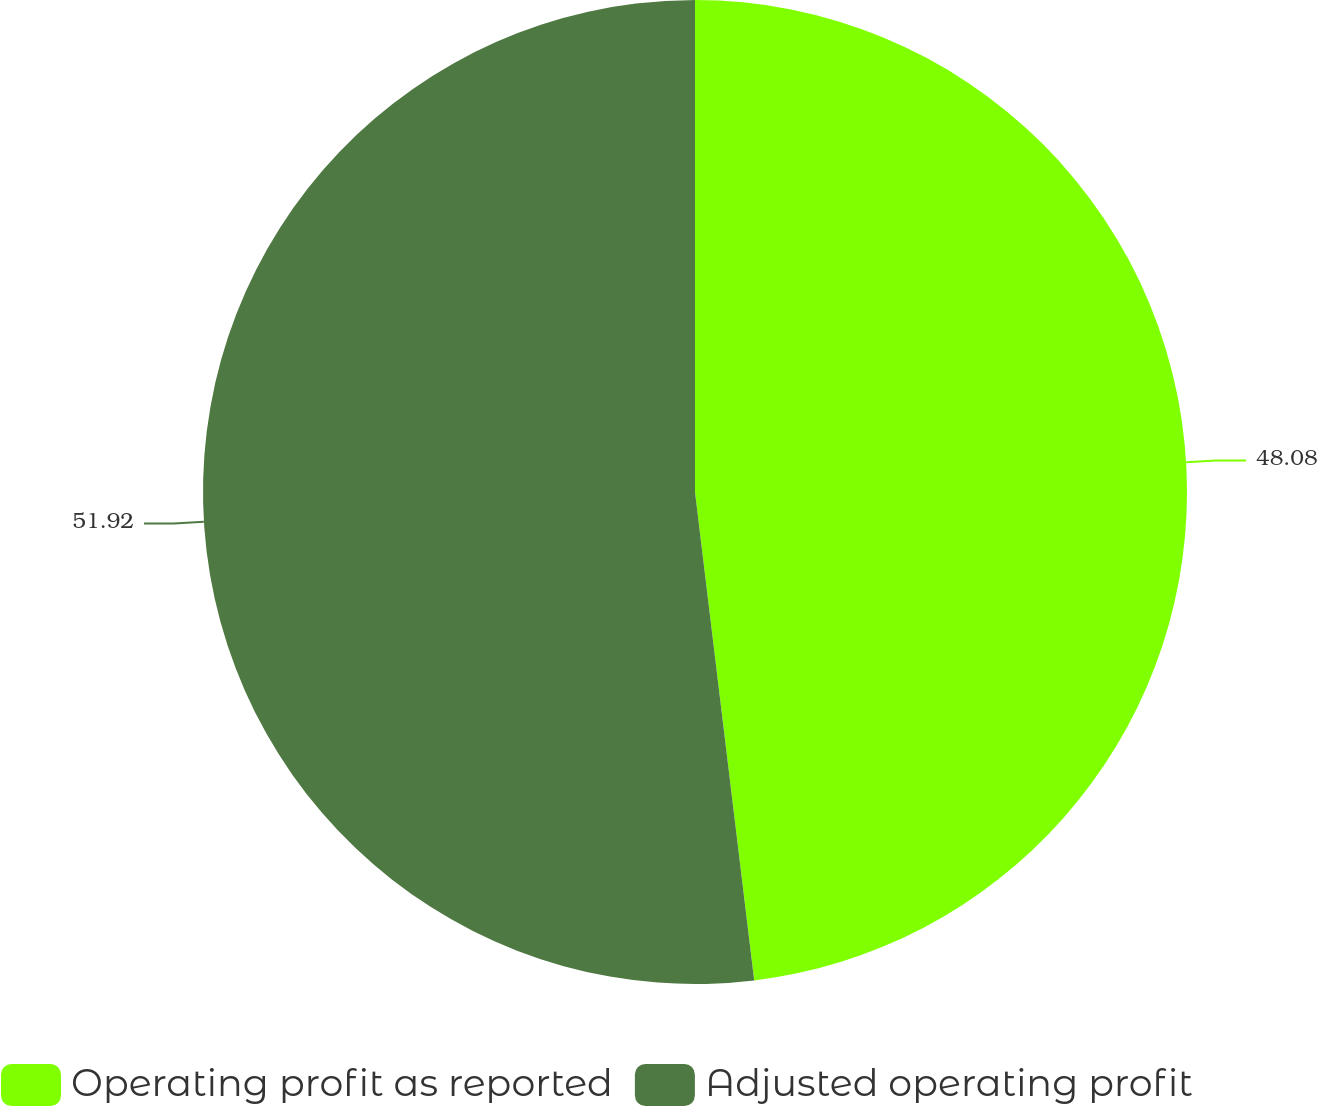<chart> <loc_0><loc_0><loc_500><loc_500><pie_chart><fcel>Operating profit as reported<fcel>Adjusted operating profit<nl><fcel>48.08%<fcel>51.92%<nl></chart> 